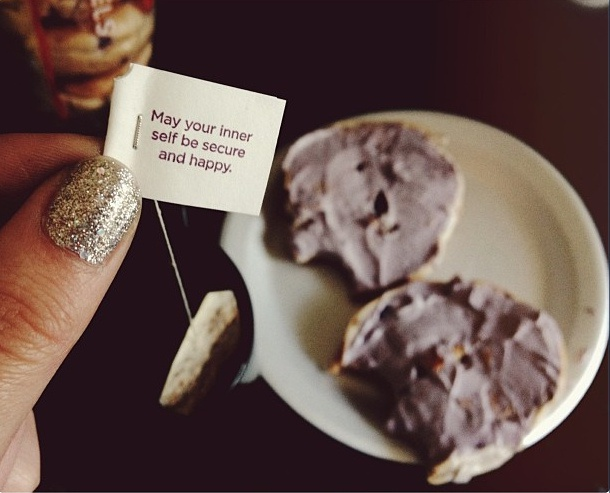Describe the objects in this image and their specific colors. I can see dining table in black, darkgray, maroon, lightgray, and gray tones, donut in maroon, darkgray, gray, brown, and black tones, people in maroon, tan, and gray tones, donut in maroon, darkgray, gray, and black tones, and cup in maroon, black, brown, and tan tones in this image. 